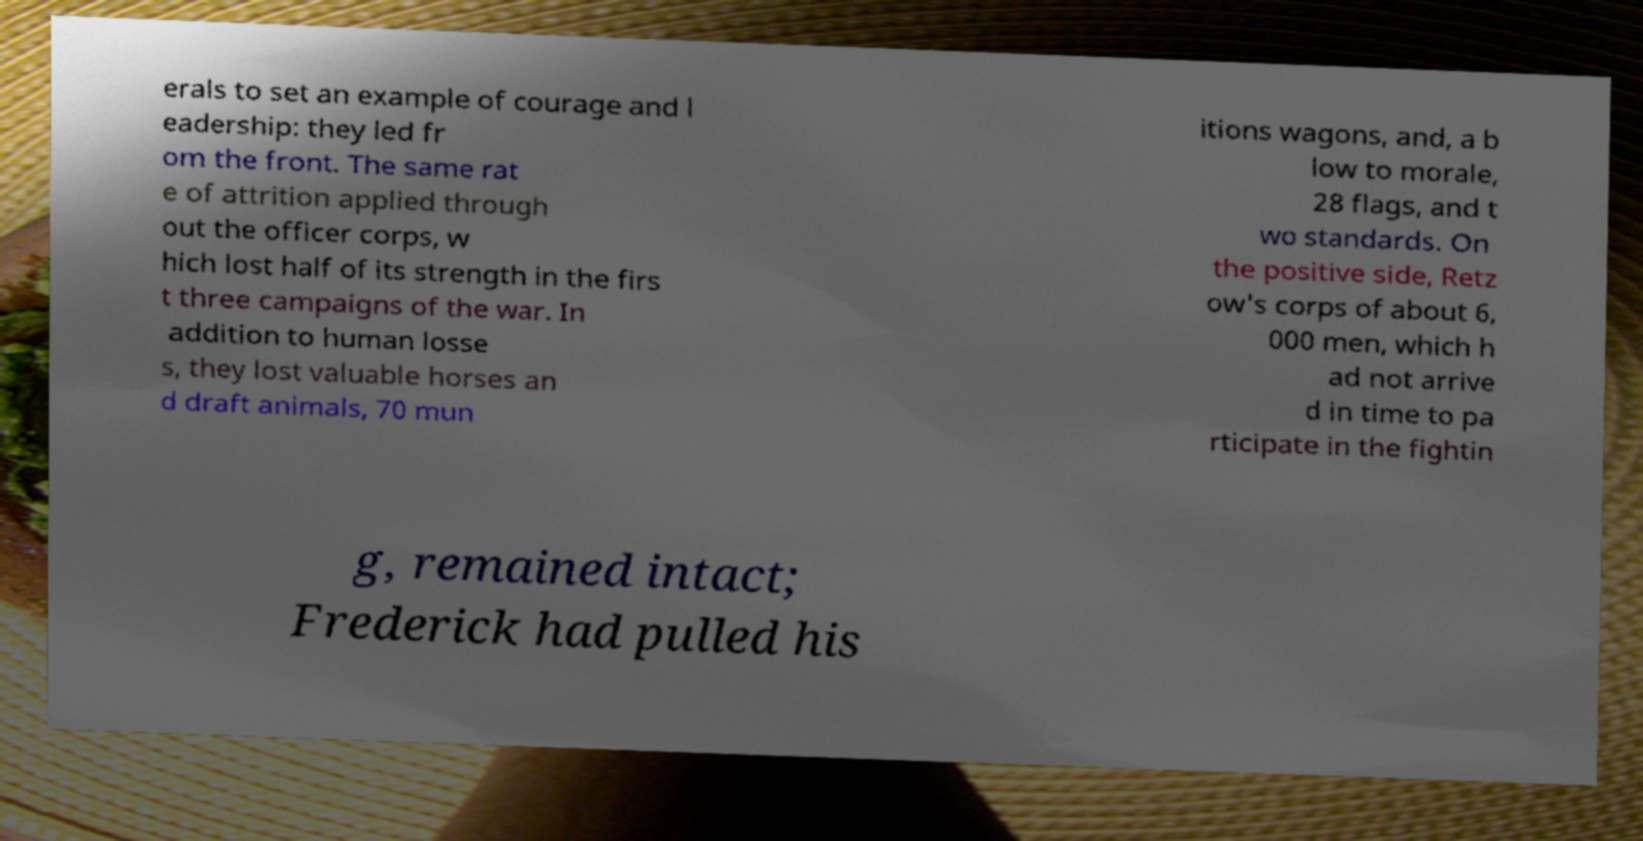What messages or text are displayed in this image? I need them in a readable, typed format. erals to set an example of courage and l eadership: they led fr om the front. The same rat e of attrition applied through out the officer corps, w hich lost half of its strength in the firs t three campaigns of the war. In addition to human losse s, they lost valuable horses an d draft animals, 70 mun itions wagons, and, a b low to morale, 28 flags, and t wo standards. On the positive side, Retz ow's corps of about 6, 000 men, which h ad not arrive d in time to pa rticipate in the fightin g, remained intact; Frederick had pulled his 